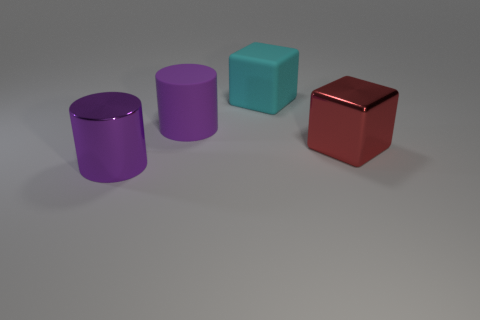Add 4 big objects. How many objects exist? 8 Subtract 0 gray spheres. How many objects are left? 4 Subtract all yellow cubes. Subtract all metal cubes. How many objects are left? 3 Add 4 cylinders. How many cylinders are left? 6 Add 3 purple cylinders. How many purple cylinders exist? 5 